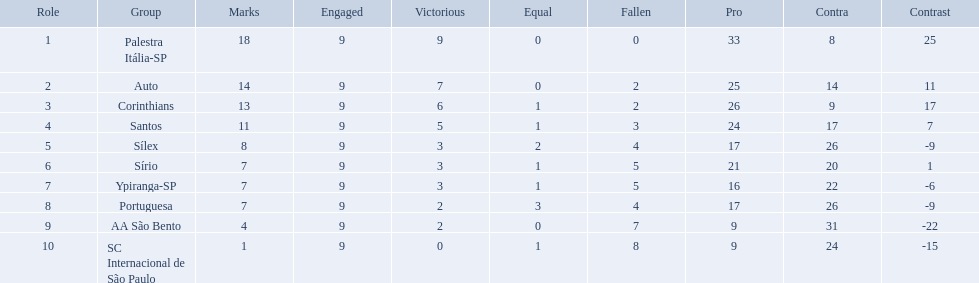What teams played in 1926? Palestra Itália-SP, Auto, Corinthians, Santos, Sílex, Sírio, Ypiranga-SP, Portuguesa, AA São Bento, SC Internacional de São Paulo. Did any team lose zero games? Palestra Itália-SP. Which teams were playing brazilian football in 1926? Palestra Itália-SP, Auto, Corinthians, Santos, Sílex, Sírio, Ypiranga-SP, Portuguesa, AA São Bento, SC Internacional de São Paulo. Of those teams, which one scored 13 points? Corinthians. How many points were scored by the teams? 18, 14, 13, 11, 8, 7, 7, 7, 4, 1. What team scored 13 points? Corinthians. How many teams played football in brazil during the year 1926? Palestra Itália-SP, Auto, Corinthians, Santos, Sílex, Sírio, Ypiranga-SP, Portuguesa, AA São Bento, SC Internacional de São Paulo. What was the highest number of games won during the 1926 season? 9. Which team was in the top spot with 9 wins for the 1926 season? Palestra Itália-SP. What were the top three amounts of games won for 1926 in brazilian football season? 9, 7, 6. What were the top amount of games won for 1926 in brazilian football season? 9. What team won the top amount of games Palestra Itália-SP. 